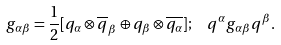<formula> <loc_0><loc_0><loc_500><loc_500>g _ { \alpha \beta } = \frac { 1 } { 2 } [ q _ { \alpha } \otimes \overline { q } _ { \beta } \oplus q _ { \beta } \otimes \overline { q _ { \alpha } } ] ; \ \ q ^ { \alpha } g _ { \alpha \beta } q ^ { \beta } .</formula> 